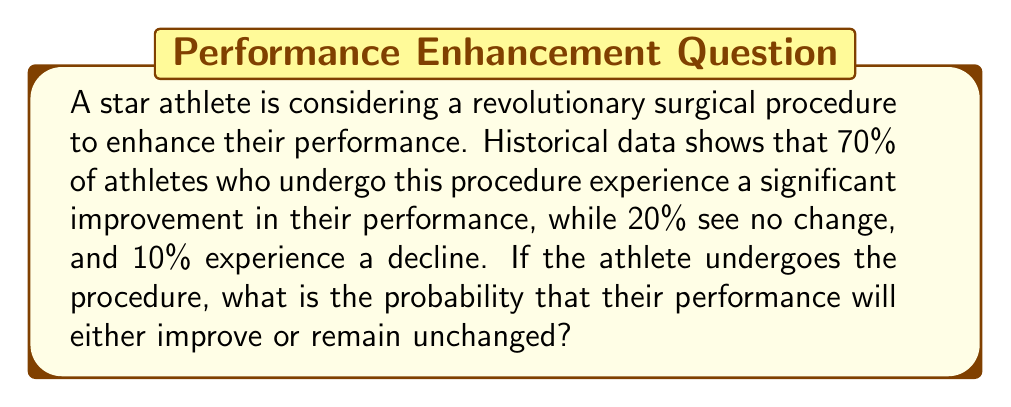What is the answer to this math problem? Let's approach this step-by-step:

1) We are given the following probabilities:
   P(Improvement) = 70% = 0.70
   P(No change) = 20% = 0.20
   P(Decline) = 10% = 0.10

2) We need to find the probability that the performance will either improve or remain unchanged. This is the sum of the probabilities of these two events.

3) We can express this mathematically as:
   $$P(\text{Improve or No change}) = P(\text{Improve}) + P(\text{No change})$$

4) Substituting the values:
   $$P(\text{Improve or No change}) = 0.70 + 0.20$$

5) Calculating:
   $$P(\text{Improve or No change}) = 0.90$$

6) We can verify this by noting that the sum of all probabilities should equal 1:
   $$0.70 + 0.20 + 0.10 = 1.00$$

Therefore, the probability that the athlete's performance will either improve or remain unchanged after the surgery is 0.90 or 90%.
Answer: 0.90 